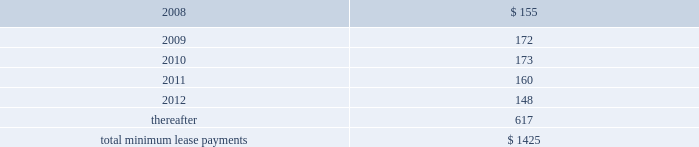Notes to consolidated financial statements ( continued ) note 8 2014commitments and contingencies ( continued ) provide renewal options for terms of 3 to 7 additional years .
Leases for retail space are for terms of 5 to 20 years , the majority of which are for 10 years , and often contain multi-year renewal options .
As of september 29 , 2007 , the company 2019s total future minimum lease payments under noncancelable operating leases were $ 1.4 billion , of which $ 1.1 billion related to leases for retail space .
Rent expense under all operating leases , including both cancelable and noncancelable leases , was $ 151 million , $ 138 million , and $ 140 million in 2007 , 2006 , and 2005 , respectively .
Future minimum lease payments under noncancelable operating leases having remaining terms in excess of one year as of september 29 , 2007 , are as follows ( in millions ) : fiscal years .
Accrued warranty and indemnifications the company offers a basic limited parts and labor warranty on its hardware products .
The basic warranty period for hardware products is typically one year from the date of purchase by the end-user .
The company also offers a 90-day basic warranty for its service parts used to repair the company 2019s hardware products .
The company provides currently for the estimated cost that may be incurred under its basic limited product warranties at the time related revenue is recognized .
Factors considered in determining appropriate accruals for product warranty obligations include the size of the installed base of products subject to warranty protection , historical and projected warranty claim rates , historical and projected cost-per-claim , and knowledge of specific product failures that are outside of the company 2019s typical experience .
The company assesses the adequacy of its preexisting warranty liabilities and adjusts the amounts as necessary based on actual experience and changes in future estimates .
For products accounted for under subscription accounting pursuant to sop no .
97-2 , the company recognizes warranty expense as incurred .
The company periodically provides updates to its applications and system software to maintain the software 2019s compliance with specifications .
The estimated cost to develop such updates is accounted for as warranty costs that are recognized at the time related software revenue is recognized .
Factors considered in determining appropriate accruals related to such updates include the number of units delivered , the number of updates expected to occur , and the historical cost and estimated future cost of the resources necessary to develop these updates. .
What percentage of future minimum lease payments under noncancelable operating leases having remaining terms in excess of one year are due in 2010? 
Computations: (173 / 1425)
Answer: 0.1214. 